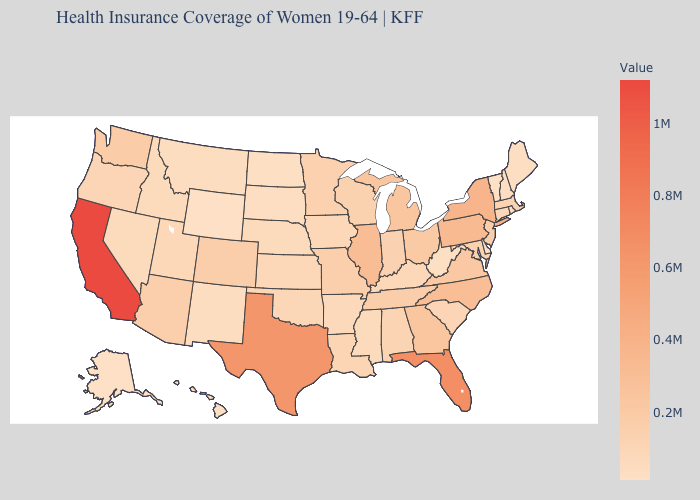Which states have the lowest value in the MidWest?
Give a very brief answer. North Dakota. Which states have the lowest value in the South?
Quick response, please. Delaware. Does Alaska have the lowest value in the USA?
Concise answer only. Yes. 